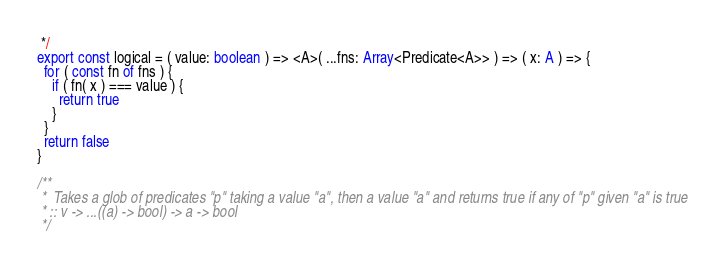Convert code to text. <code><loc_0><loc_0><loc_500><loc_500><_TypeScript_> */
export const logical = ( value: boolean ) => <A>( ...fns: Array<Predicate<A>> ) => ( x: A ) => {
  for ( const fn of fns ) {
    if ( fn( x ) === value ) {
      return true
    }
  }
  return false
}

/**
 *  Takes a glob of predicates "p" taking a value "a", then a value "a" and returns true if any of "p" given "a" is true
 * :: v -> ...((a) -> bool) -> a -> bool
 */</code> 